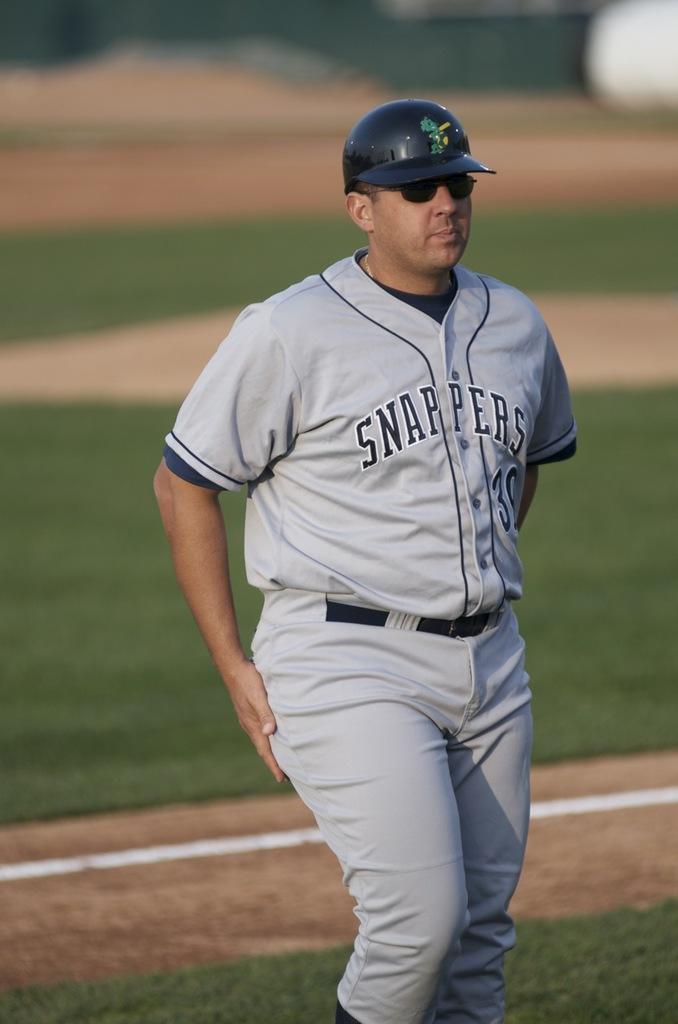What is the baseball team name on the jersey?
Provide a succinct answer. Snappers. 